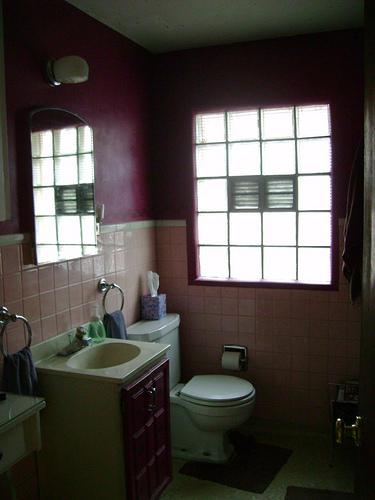How many windows are there?
Give a very brief answer. 1. What room of the house is this?
Give a very brief answer. Bathroom. Is there toilet paper next to the toilet?
Quick response, please. Yes. 